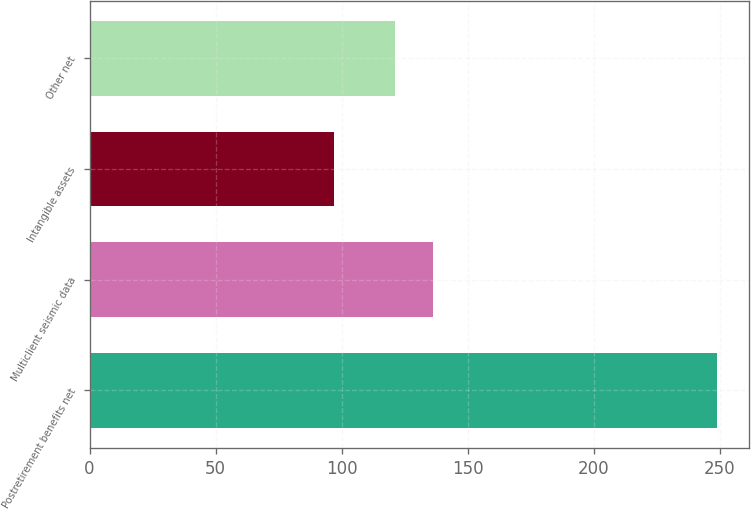Convert chart. <chart><loc_0><loc_0><loc_500><loc_500><bar_chart><fcel>Postretirement benefits net<fcel>Multiclient seismic data<fcel>Intangible assets<fcel>Other net<nl><fcel>249<fcel>136.2<fcel>97<fcel>121<nl></chart> 